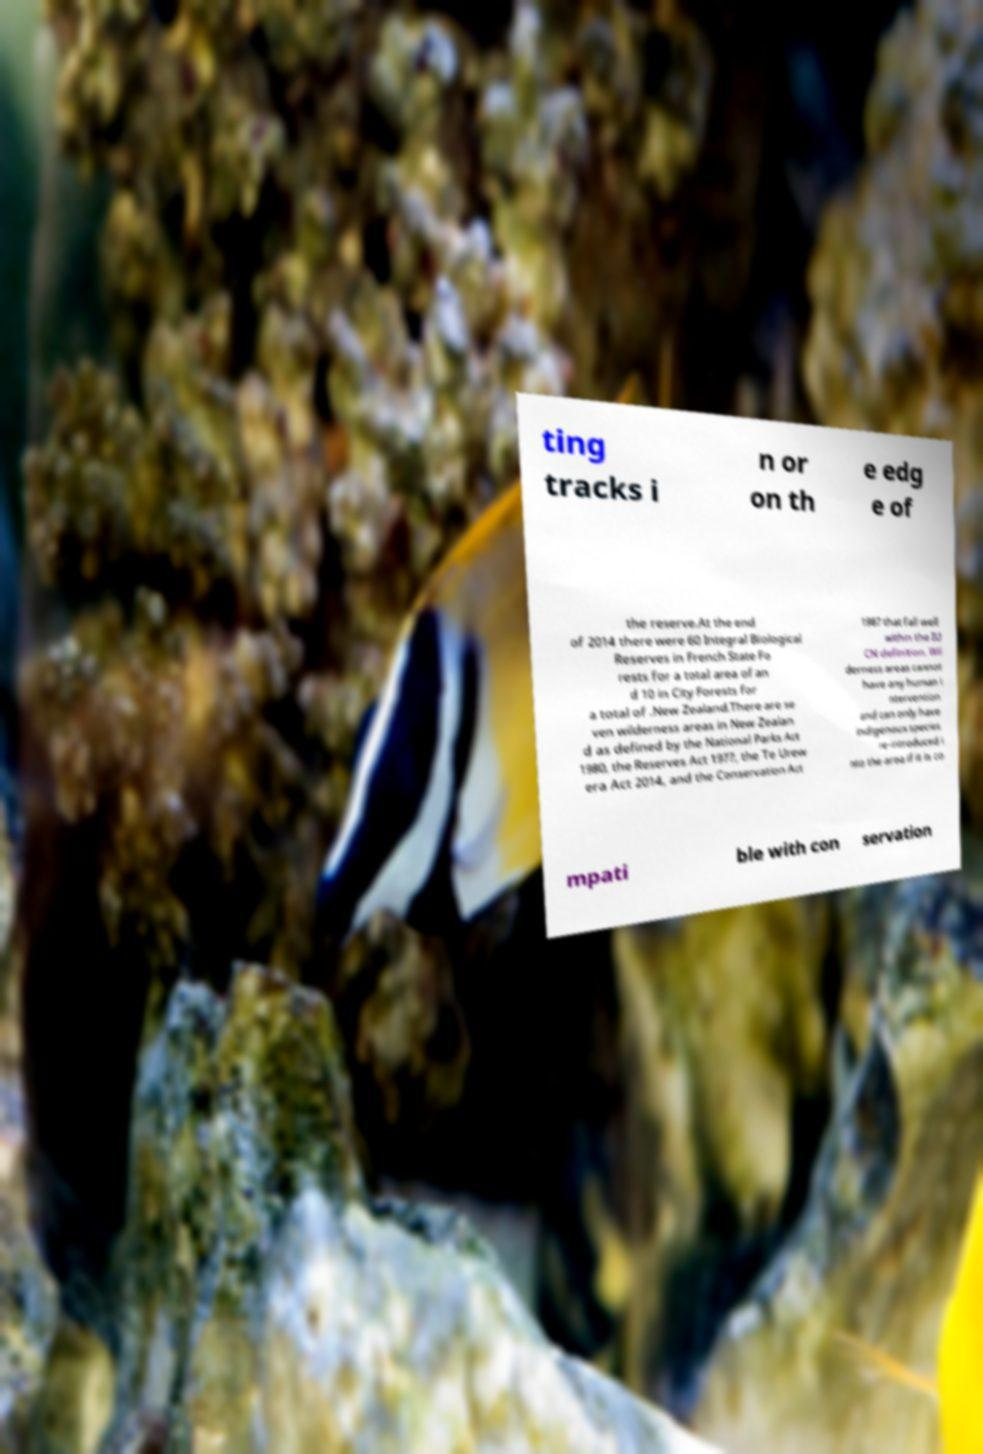For documentation purposes, I need the text within this image transcribed. Could you provide that? ting tracks i n or on th e edg e of the reserve.At the end of 2014 there were 60 Integral Biological Reserves in French State Fo rests for a total area of an d 10 in City Forests for a total of .New Zealand.There are se ven wilderness areas in New Zealan d as defined by the National Parks Act 1980, the Reserves Act 1977, the Te Urew era Act 2014, and the Conservation Act 1987 that fall well within the IU CN definition. Wil derness areas cannot have any human i ntervention and can only have indigenous species re-introduced i nto the area if it is co mpati ble with con servation 